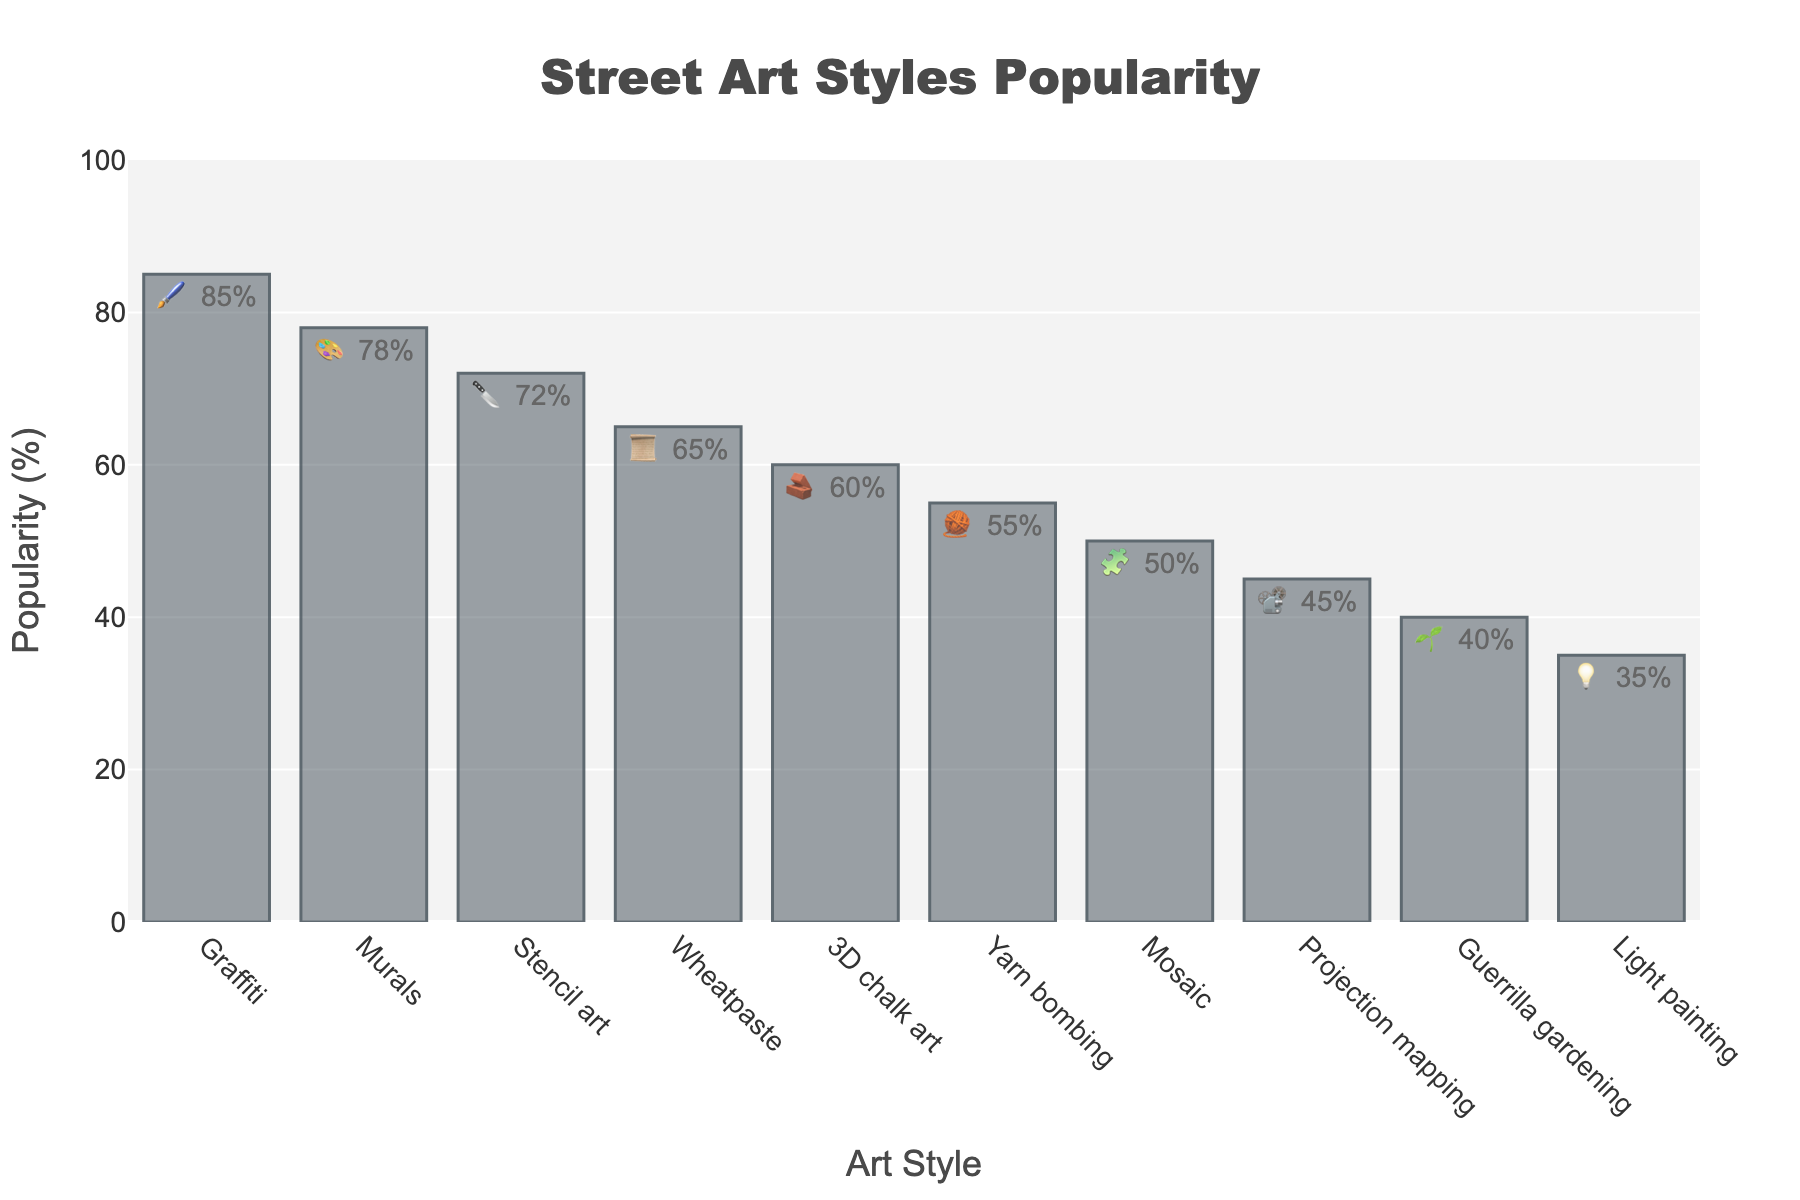what is the least popular street art style based on the plot? To determine the least popular street art style, look for the bar representing the smallest value along the y-axis labeled "Popularity (%)." From the plot, the "Light painting" style is at the bottom with 35% popularity.
Answer: Light painting What is the average popularity of the top 3 street art styles? To find the average popularity, sum the popularity percentages of the top 3 street art styles and divide by 3. The top 3 styles are Graffiti (85%), Murals (78%), and Stencil art (72%). The sum is 85+78+72 = 235, so the average is 235/3.
Answer: 78.3% Which street art style has a popularity between Mosaic and Projection mapping? From the plot, Mosaic has a popularity of 50% and Projection mapping has 45%. Wheatpaste, with 65%, falls between the Mosaic and Projection mapping styles.
Answer: Wheatpaste How much more popular is Graffiti compared to 3D chalk art? To find how much more popular Graffiti is compared to 3D chalk art, subtract the popularity of 3D chalk art from Graffiti. Graffiti has 85% and 3D chalk art has 60%. 85 - 60 = 25.
Answer: 25% Which style uses the emoji 📜 and how popular is it? Identify the bar with the text label containing the 📜 emoji. In the plot, Wheatpaste uses the 📜 emoji and has a popularity of 65%.
Answer: Wheatpaste, 65% What is the combined popularity of yarn bombing and guerrilla gardening? Sum the popularity percentages of yarn bombing and guerrilla gardening. Yarn bombing has 55% and guerrilla gardening has 40%. So, 55 + 40 = 95.
Answer: 95% What is the median popularity of all the street art styles? To find the median, list all the popularity percentages in ascending order, and the median is the middle value or the average of the two middle values if there is an even number of entries. The percentages are: 35, 40, 45, 50, 55, 60, 65, 72, 78, 85. The middle values are 55 and 60. The average of 55 and 60 is (55+60)/2 = 57.5.
Answer: 57.5% Which street art style uses the emoji 💡? Look for the text label in the plot that contains the 💡 emoji. The style associated with this emoji is Light painting.
Answer: Light painting 